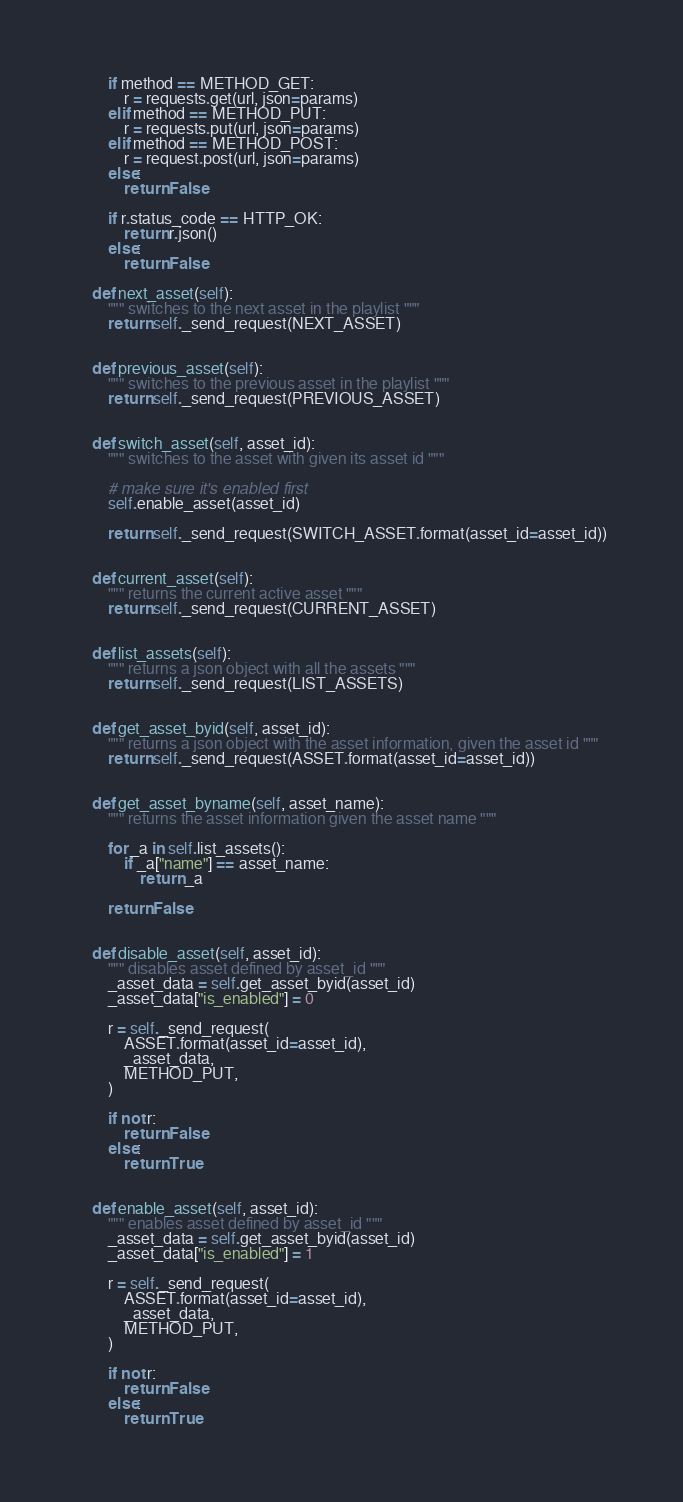<code> <loc_0><loc_0><loc_500><loc_500><_Python_>
        if method == METHOD_GET:
            r = requests.get(url, json=params)
        elif method == METHOD_PUT:
            r = requests.put(url, json=params)
        elif method == METHOD_POST:
            r = request.post(url, json=params)
        else:
            return False
        
        if r.status_code == HTTP_OK:
            return r.json()
        else:
            return False

    def next_asset(self):
        """ switches to the next asset in the playlist """
        return self._send_request(NEXT_ASSET)

    
    def previous_asset(self):
        """ switches to the previous asset in the playlist """
        return self._send_request(PREVIOUS_ASSET)

    
    def switch_asset(self, asset_id):
        """ switches to the asset with given its asset id """

        # make sure it's enabled first
        self.enable_asset(asset_id)
        
        return self._send_request(SWITCH_ASSET.format(asset_id=asset_id))


    def current_asset(self):
        """ returns the current active asset """
        return self._send_request(CURRENT_ASSET)


    def list_assets(self):
        """ returns a json object with all the assets """
        return self._send_request(LIST_ASSETS)


    def get_asset_byid(self, asset_id):
        """ returns a json object with the asset information, given the asset id """
        return self._send_request(ASSET.format(asset_id=asset_id))


    def get_asset_byname(self, asset_name):
        """ returns the asset information given the asset name """
        
        for _a in self.list_assets():
            if _a["name"] == asset_name:
                return _a

        return False


    def disable_asset(self, asset_id):
        """ disables asset defined by asset_id """
        _asset_data = self.get_asset_byid(asset_id)
        _asset_data["is_enabled"] = 0

        r = self._send_request(
            ASSET.format(asset_id=asset_id),
            _asset_data,
            METHOD_PUT,
        )

        if not r:
            return False
        else:
            return True


    def enable_asset(self, asset_id):
        """ enables asset defined by asset_id """
        _asset_data = self.get_asset_byid(asset_id)
        _asset_data["is_enabled"] = 1

        r = self._send_request(
            ASSET.format(asset_id=asset_id),
            _asset_data,
            METHOD_PUT,
        )

        if not r:
            return False
        else:
            return True
</code> 